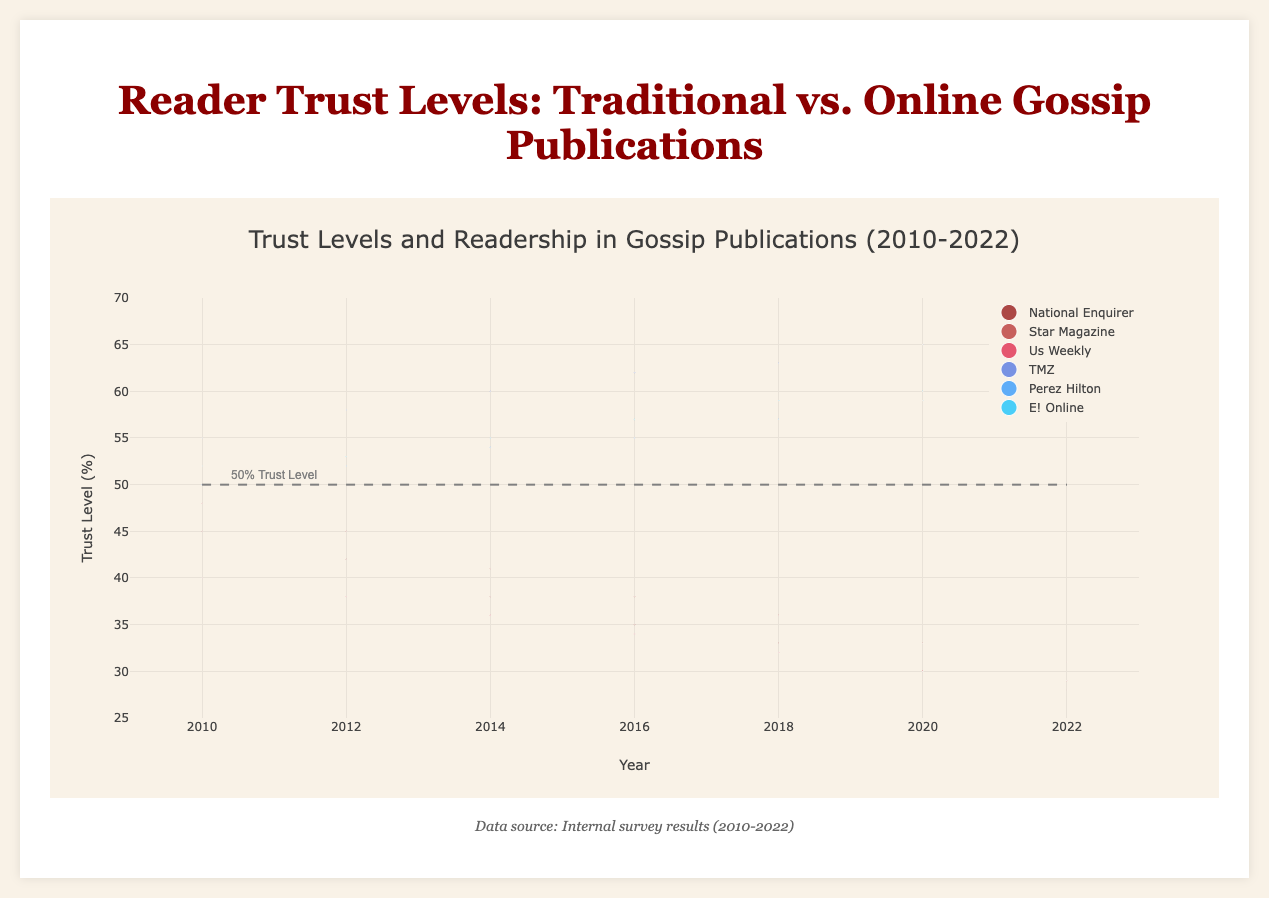What's the title of the figure? The title of the figure is usually found at the top and provides an overview of what the figure represents. In this case, it reads "Reader Trust Levels: Traditional vs. Online Gossip Publications."
Answer: Reader Trust Levels: Traditional vs. Online Gossip Publications In what year did "TMZ" have the highest trust level? To find when "TMZ" had the highest trust level, look at the data points for TMZ and locate the one with the greatest trust percentage. TMZ's highest trust level is in 2022 at 67%.
Answer: 2022 How does the trust level of "National Enquirer" change over time? Observe the trend of "National Enquirer" data points over the years on the y-axis. The trust level consistently decreases from 45% in 2010 to 28% in 2022.
Answer: Decreases Which publication has the largest readership size in 2016? To identify the publication with the largest readership, look for the biggest bubble in the 2016 column. TMZ has the largest bubble, indicating the highest readership of 670,000.
Answer: TMZ How do the sizes of the bubbles correspond to the data in the chart? The bubbles' sizes correlate with readership numbers. Larger bubbles represent higher readership. Each point’s bubble size is proportional to the readership divided by a constant factor to fit the visual scale.
Answer: Proportional to readership Compare the trust levels of "Star Magazine" and "Perez Hilton" in 2014. Check the y-values for both "Star Magazine" and "Perez Hilton" in 2014. "Star Magazine" has a trust level of 41%, while "Perez Hilton" has a trust level of 54%. "Perez Hilton" has a higher trust level.
Answer: Perez Hilton > Star Magazine What is the general trend of trust levels for online gossip publications from 2010 to 2022? Reviewing the data points for online gossip publications like TMZ, Perez Hilton, and E! Online from 2010 to 2022 shows trust levels either increased or remained stable, indicating a general upward trend.
Answer: Upward trend What is the average trust level of "Us Weekly" in 2020 and 2022? To compute the average, add the trust levels of "Us Weekly" in 2020 (30%) and 2022 (29%), then divide by 2. (30 + 29) / 2 = 29.5
Answer: 29.5 Which year did "E! Online" surpass the 60% trust level? Look for when "E! Online's" trust levels first exceeded 60%. This occurs in 2020 when the trust level is exactly 60%, and again in 2022 when the trust level increases to 62%.
Answer: 2022 How does the change in trust level for traditional gossip magazines compare to online gossip publications from 2010 to 2022? Compare the overall trends. Traditional gossip magazines like "National Enquirer," "Star Magazine," and "Us Weekly" show a decreasing trend, while online publications like "TMZ," "Perez Hilton," and "E! Online" show an increasing or stable trend, reflecting trust loss in traditional magazines and gain in online publications.
Answer: Traditional: Decrease, Online: Increase 